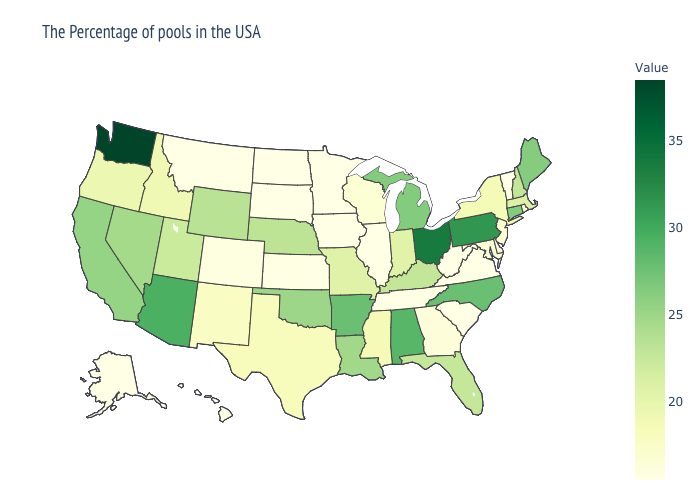Does Massachusetts have a lower value than Colorado?
Be succinct. No. Which states have the lowest value in the Northeast?
Write a very short answer. Vermont. Among the states that border Kansas , does Nebraska have the highest value?
Be succinct. No. Does Florida have the lowest value in the South?
Quick response, please. No. 